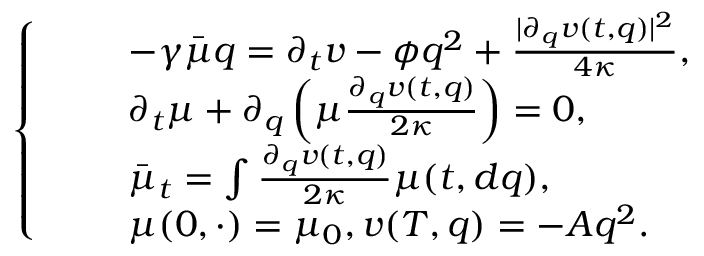Convert formula to latex. <formula><loc_0><loc_0><loc_500><loc_500>\left \{ \begin{array} { r l } & { \quad - \gamma \bar { \mu } q = \partial _ { t } v - \phi q ^ { 2 } + \frac { | \partial _ { q } v ( t , q ) | ^ { 2 } } { 4 \kappa } , } \\ & { \quad \partial _ { t } \mu + \partial _ { q } \left ( \mu \frac { \partial _ { q } v ( t , q ) } { 2 \kappa } \right ) = 0 , } \\ & { \quad \bar { \mu } _ { t } = \int \frac { \partial _ { q } v ( t , q ) } { 2 \kappa } \mu ( t , d q ) , } \\ & { \quad \mu ( 0 , \cdot ) = \mu _ { 0 } , v ( T , q ) = - A q ^ { 2 } . } \end{array}</formula> 